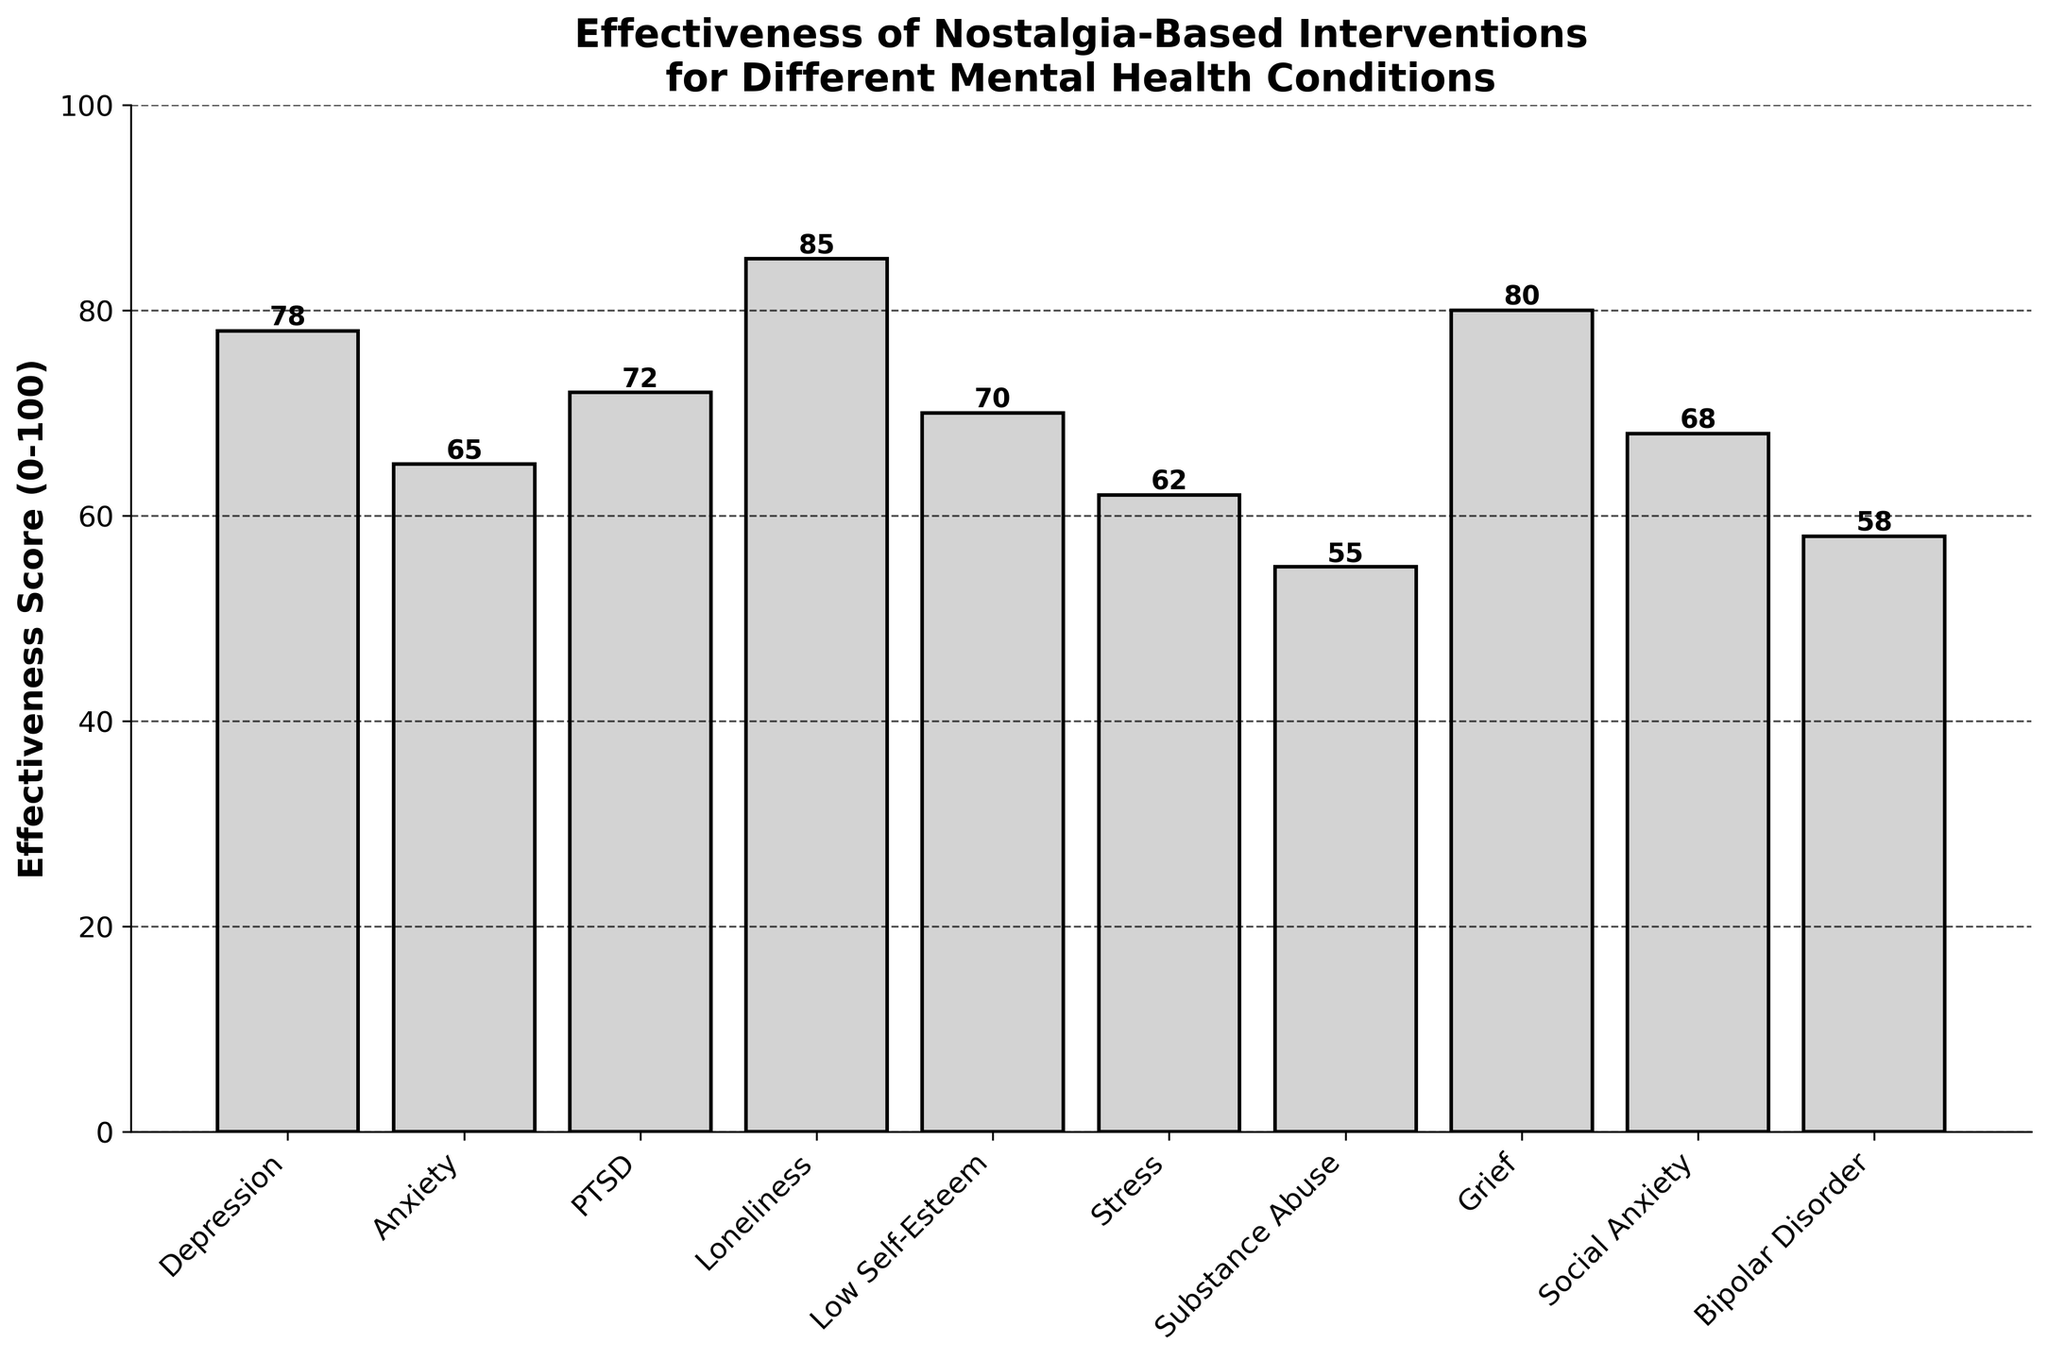Which mental health condition has the highest effectiveness score? Look at the bar with the greatest height, which represents the highest effectiveness score. The corresponding mental health condition's label shows "Loneliness" with a score of 85.
Answer: Loneliness Which mental health condition has the lowest effectiveness score? Look at the shortest bar in the chart, representing the lowest effectiveness score. The corresponding mental health condition's label shows "Substance Abuse" with a score of 55.
Answer: Substance Abuse How many conditions have an effectiveness score above 70? Count the number of bars whose heights exceed the 70 mark on the y-axis. The conditions are "Depression," "PTSD," "Loneliness," "Grief." There are 4 bars in total.
Answer: 4 What is the difference in effectiveness scores between Grief and Stress? Identify the bars for Grief and Stress. Grief has a score of 80 and Stress has a score of 62. Subtract the scores: 80 - 62 = 18.
Answer: 18 Is the effectiveness score for Bipolar Disorder greater than 60? Identify the bar for Bipolar Disorder. Its score is 58, which is below 60.
Answer: No What is the average effectiveness score for the conditions Anxiety, PTSD, and Low Self-Esteem? Identify the scores for Anxiety (65), PTSD (72), and Low Self-Esteem (70). Add the scores: 65 + 72 + 70 = 207. Divide by 3 to get the average: 207 / 3 = 69.
Answer: 69 Which two conditions have the most similar effectiveness scores? Compare the heights of the bars to find the closest scores. Anxiety (65) and Social Anxiety (68) have the closest scores, with a difference of 3.
Answer: Anxiety and Social Anxiety Among Depression, Grief, and Loneliness, which has the median score? Identify the scores for Depression (78), Grief (80), and Loneliness (85). Sort them: 78, 80, 85. The middle value (median) is 80.
Answer: Grief By how much does the effectiveness score for Social Anxiety exceed that for Bipolar Disorder? Identify the scores for Social Anxiety (68) and Bipolar Disorder (58). Subtract the scores: 68 - 58 = 10.
Answer: 10 